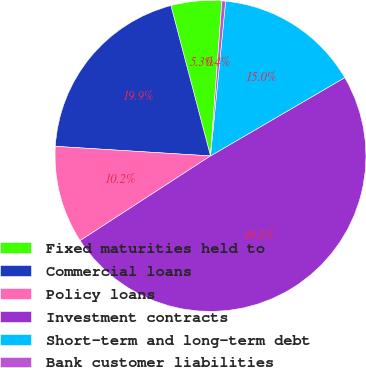Convert chart. <chart><loc_0><loc_0><loc_500><loc_500><pie_chart><fcel>Fixed maturities held to<fcel>Commercial loans<fcel>Policy loans<fcel>Investment contracts<fcel>Short-term and long-term debt<fcel>Bank customer liabilities<nl><fcel>5.27%<fcel>19.92%<fcel>10.15%<fcel>49.23%<fcel>15.04%<fcel>0.38%<nl></chart> 